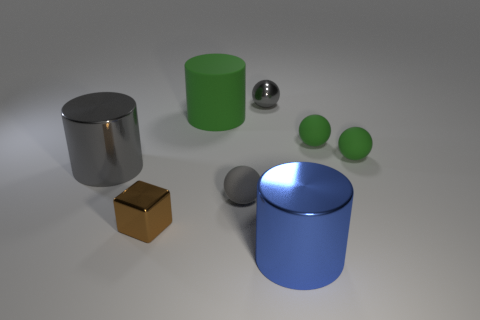Subtract all green cylinders. How many cylinders are left? 2 Subtract all blocks. How many objects are left? 7 Subtract 1 cylinders. How many cylinders are left? 2 Subtract all gray spheres. Subtract all blue cubes. How many spheres are left? 2 Subtract all purple cylinders. How many yellow spheres are left? 0 Subtract all small matte objects. Subtract all blue shiny things. How many objects are left? 4 Add 8 big metallic things. How many big metallic things are left? 10 Add 1 big gray cylinders. How many big gray cylinders exist? 2 Add 2 shiny cubes. How many objects exist? 10 Subtract all gray spheres. How many spheres are left? 2 